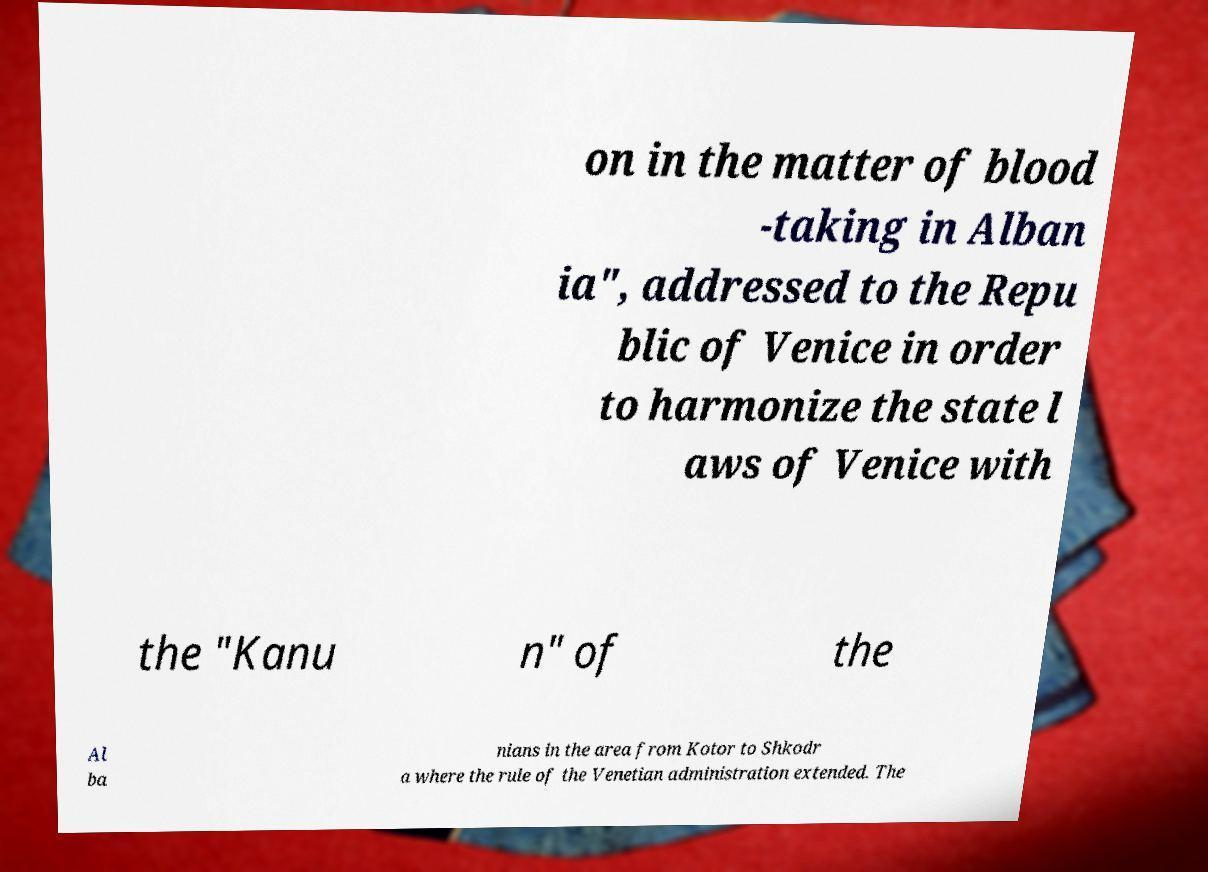I need the written content from this picture converted into text. Can you do that? on in the matter of blood -taking in Alban ia", addressed to the Repu blic of Venice in order to harmonize the state l aws of Venice with the "Kanu n" of the Al ba nians in the area from Kotor to Shkodr a where the rule of the Venetian administration extended. The 